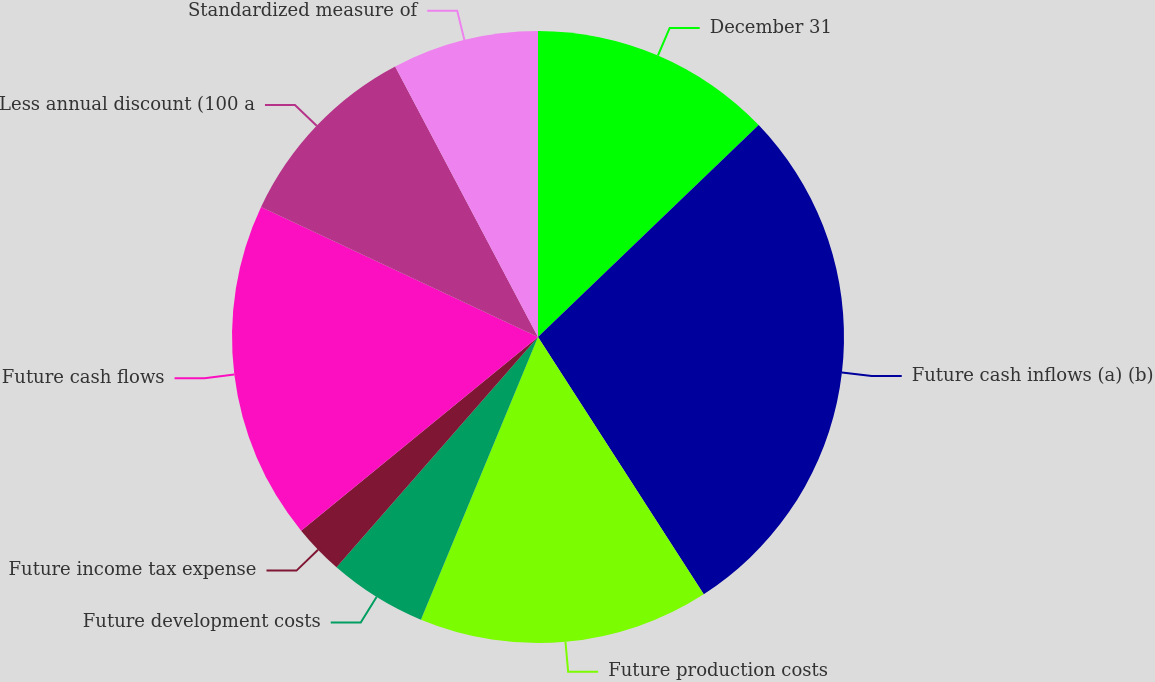Convert chart to OTSL. <chart><loc_0><loc_0><loc_500><loc_500><pie_chart><fcel>December 31<fcel>Future cash inflows (a) (b)<fcel>Future production costs<fcel>Future development costs<fcel>Future income tax expense<fcel>Future cash flows<fcel>Less annual discount (100 a<fcel>Standardized measure of<nl><fcel>12.82%<fcel>28.07%<fcel>15.36%<fcel>5.19%<fcel>2.65%<fcel>17.9%<fcel>10.28%<fcel>7.73%<nl></chart> 